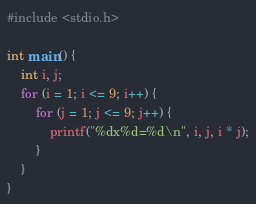<code> <loc_0><loc_0><loc_500><loc_500><_C_>#include <stdio.h>

int main() {
    int i, j;
    for (i = 1; i <= 9; i++) {
        for (j = 1; j <= 9; j++) {
            printf("%dx%d=%d\n", i, j, i * j);
        }
    }
}

</code> 